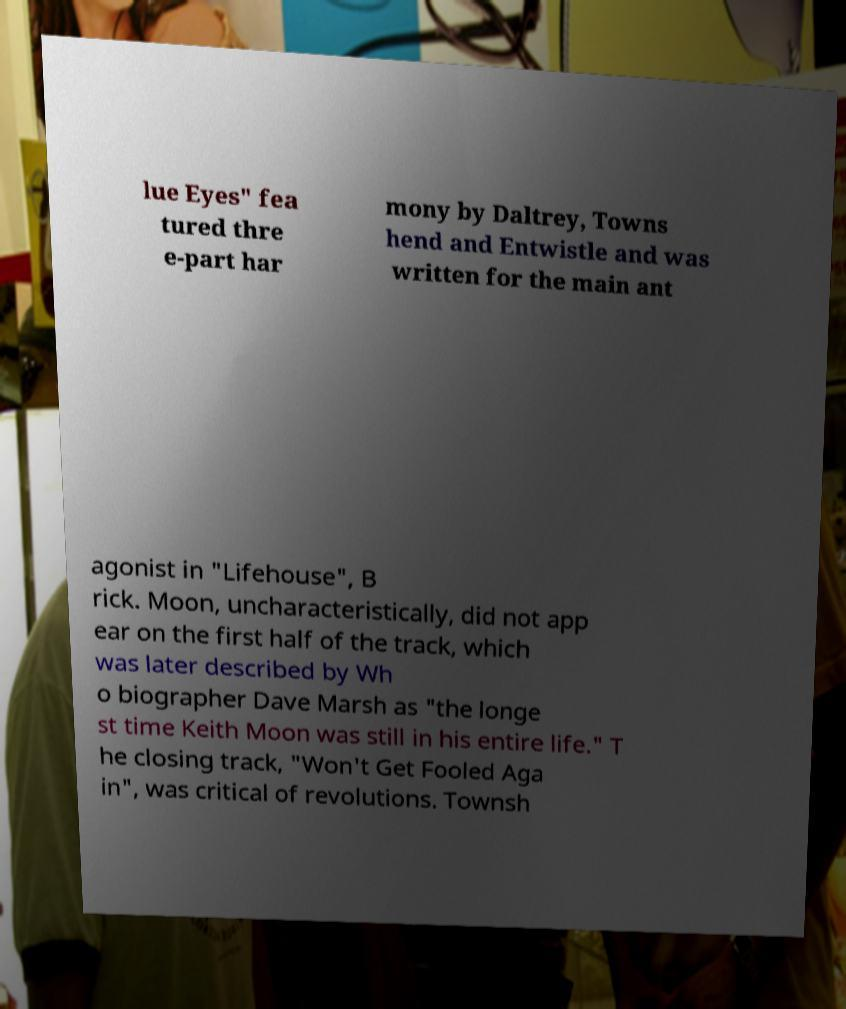There's text embedded in this image that I need extracted. Can you transcribe it verbatim? lue Eyes" fea tured thre e-part har mony by Daltrey, Towns hend and Entwistle and was written for the main ant agonist in "Lifehouse", B rick. Moon, uncharacteristically, did not app ear on the first half of the track, which was later described by Wh o biographer Dave Marsh as "the longe st time Keith Moon was still in his entire life." T he closing track, "Won't Get Fooled Aga in", was critical of revolutions. Townsh 